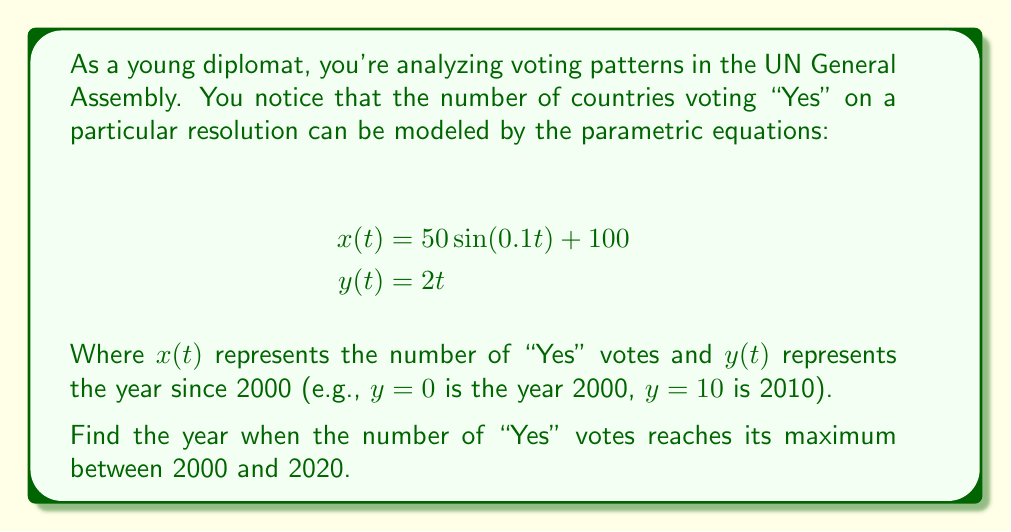Give your solution to this math problem. To solve this problem, we need to follow these steps:

1) First, we need to find the maximum value of $x(t)$ within the given time range.

2) The time range is from 2000 to 2020, which corresponds to $0 \leq y \leq 20$.

3) Since $y = 2t$, this means $0 \leq t \leq 10$.

4) The maximum of $x(t)$ will occur when $\sin(0.1t)$ reaches its maximum value of 1.

5) This happens when $0.1t = \frac{\pi}{2} + 2\pi n$, where $n$ is an integer.

6) Solving for $t$: $t = 5\pi + 20\pi n$

7) The smallest positive value of $t$ that satisfies this and is within our range is when $n=0$, so $t = 5\pi \approx 15.71$

8) To find the corresponding year, we use the equation for $y(t)$:

   $y = 2t = 2(5\pi) = 10\pi \approx 31.42$

9) Remember that $y$ represents years since 2000, so we add 2000 to this value.

10) $2000 + 31.42 \approx 2031.42$

11) However, our question asks for the maximum between 2000 and 2020. Since the true maximum occurs after 2020, the maximum within our range will be at the end of the range, which is 2020.
Answer: The number of "Yes" votes reaches its maximum in the year 2020 within the given range. 